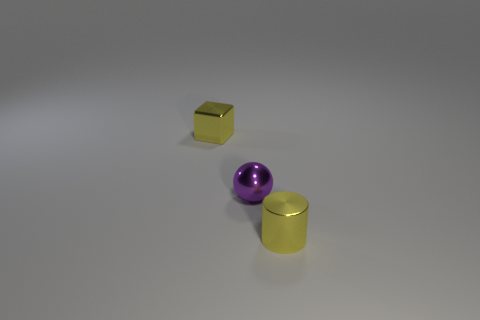Add 3 gray balls. How many objects exist? 6 Subtract all cubes. How many objects are left? 2 Add 3 yellow metallic cylinders. How many yellow metallic cylinders exist? 4 Subtract 0 blue blocks. How many objects are left? 3 Subtract all small yellow cubes. Subtract all small metal cylinders. How many objects are left? 1 Add 2 purple shiny balls. How many purple shiny balls are left? 3 